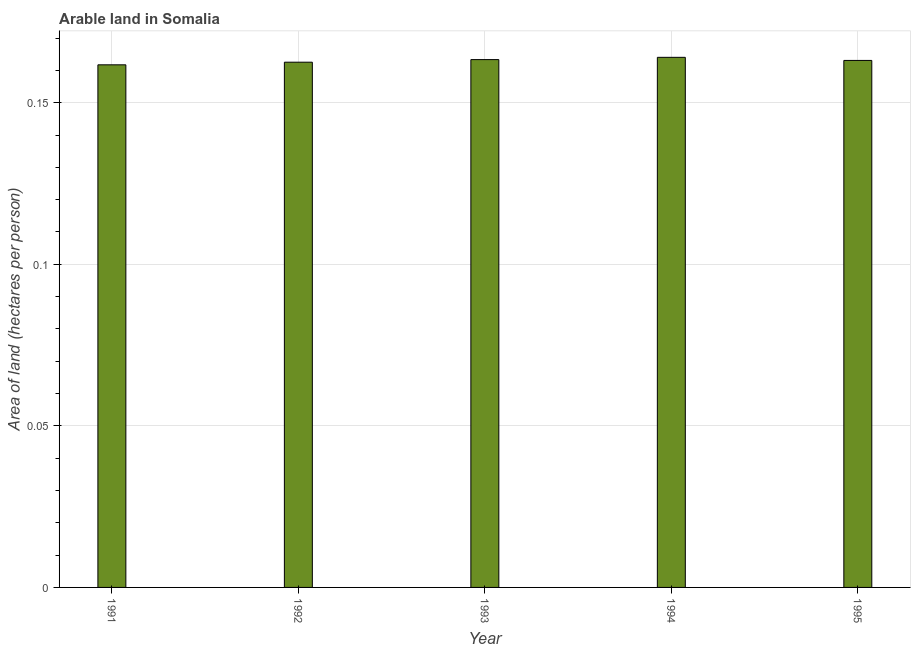Does the graph contain any zero values?
Give a very brief answer. No. What is the title of the graph?
Make the answer very short. Arable land in Somalia. What is the label or title of the Y-axis?
Keep it short and to the point. Area of land (hectares per person). What is the area of arable land in 1994?
Give a very brief answer. 0.16. Across all years, what is the maximum area of arable land?
Ensure brevity in your answer.  0.16. Across all years, what is the minimum area of arable land?
Ensure brevity in your answer.  0.16. What is the sum of the area of arable land?
Provide a short and direct response. 0.81. What is the difference between the area of arable land in 1994 and 1995?
Your answer should be compact. 0. What is the average area of arable land per year?
Your answer should be very brief. 0.16. What is the median area of arable land?
Offer a very short reply. 0.16. Do a majority of the years between 1992 and 1995 (inclusive) have area of arable land greater than 0.09 hectares per person?
Keep it short and to the point. Yes. Is the area of arable land in 1992 less than that in 1995?
Your answer should be compact. Yes. What is the difference between the highest and the second highest area of arable land?
Provide a succinct answer. 0. What is the difference between the highest and the lowest area of arable land?
Your response must be concise. 0. How many years are there in the graph?
Give a very brief answer. 5. What is the Area of land (hectares per person) of 1991?
Offer a very short reply. 0.16. What is the Area of land (hectares per person) in 1992?
Provide a short and direct response. 0.16. What is the Area of land (hectares per person) of 1993?
Keep it short and to the point. 0.16. What is the Area of land (hectares per person) in 1994?
Your response must be concise. 0.16. What is the Area of land (hectares per person) of 1995?
Offer a terse response. 0.16. What is the difference between the Area of land (hectares per person) in 1991 and 1992?
Your response must be concise. -0. What is the difference between the Area of land (hectares per person) in 1991 and 1993?
Keep it short and to the point. -0. What is the difference between the Area of land (hectares per person) in 1991 and 1994?
Keep it short and to the point. -0. What is the difference between the Area of land (hectares per person) in 1991 and 1995?
Provide a short and direct response. -0. What is the difference between the Area of land (hectares per person) in 1992 and 1993?
Your response must be concise. -0. What is the difference between the Area of land (hectares per person) in 1992 and 1994?
Provide a succinct answer. -0. What is the difference between the Area of land (hectares per person) in 1992 and 1995?
Give a very brief answer. -0. What is the difference between the Area of land (hectares per person) in 1993 and 1994?
Your response must be concise. -0. What is the difference between the Area of land (hectares per person) in 1993 and 1995?
Give a very brief answer. 0. What is the difference between the Area of land (hectares per person) in 1994 and 1995?
Offer a terse response. 0. What is the ratio of the Area of land (hectares per person) in 1991 to that in 1995?
Give a very brief answer. 0.99. What is the ratio of the Area of land (hectares per person) in 1992 to that in 1994?
Provide a short and direct response. 0.99. What is the ratio of the Area of land (hectares per person) in 1992 to that in 1995?
Your response must be concise. 1. What is the ratio of the Area of land (hectares per person) in 1993 to that in 1994?
Your answer should be very brief. 1. What is the ratio of the Area of land (hectares per person) in 1993 to that in 1995?
Provide a succinct answer. 1. What is the ratio of the Area of land (hectares per person) in 1994 to that in 1995?
Your answer should be very brief. 1.01. 